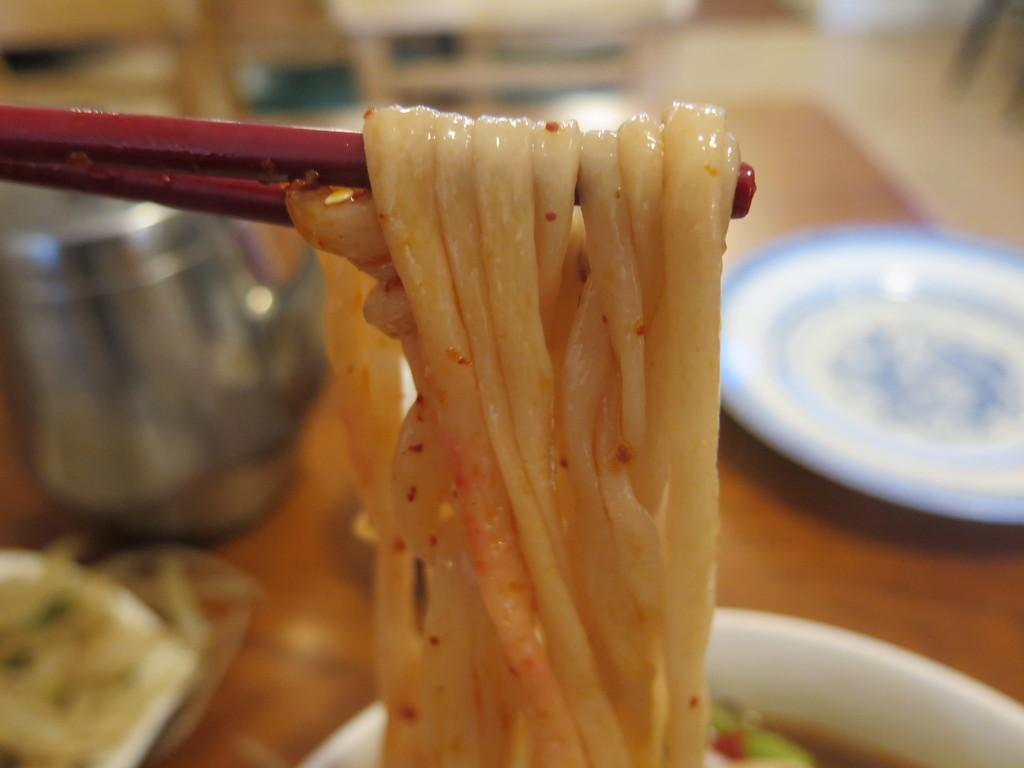What utensils are present in the image? There are chopsticks in the image. What type of food can be seen in the image? There are noodles in the image. What is on the table in the image? There is a plate, a jar, and a bowl of soup on the table in the image. What can be seen in the background of the image? The background of the image is blurry, but chairs and the floor are visible. Is there a volleyball game happening in the background of the image? No, there is no volleyball game or any reference to a volleyball in the image. What type of rail is present in the image? There is no rail present in the image. 